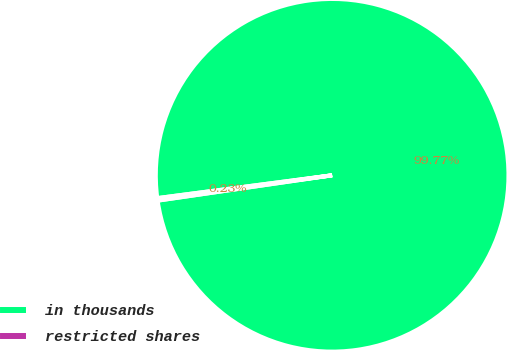Convert chart to OTSL. <chart><loc_0><loc_0><loc_500><loc_500><pie_chart><fcel>in thousands<fcel>restricted shares<nl><fcel>99.77%<fcel>0.23%<nl></chart> 